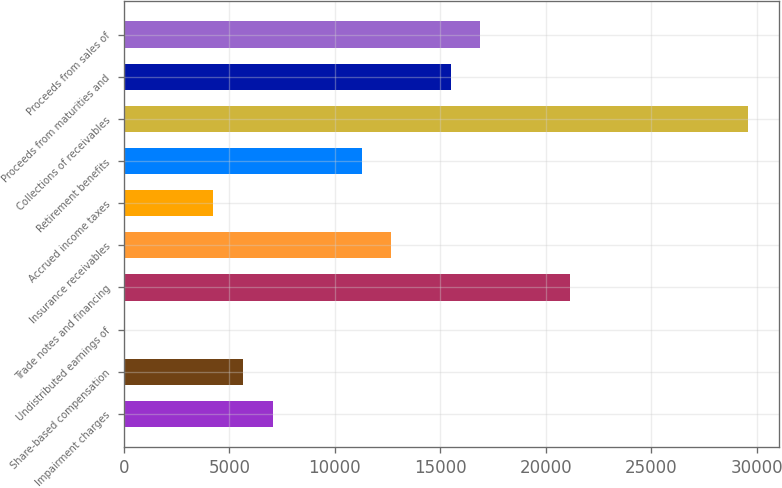Convert chart to OTSL. <chart><loc_0><loc_0><loc_500><loc_500><bar_chart><fcel>Impairment charges<fcel>Share-based compensation<fcel>Undistributed earnings of<fcel>Trade notes and financing<fcel>Insurance receivables<fcel>Accrued income taxes<fcel>Retirement benefits<fcel>Collections of receivables<fcel>Proceeds from maturities and<fcel>Proceeds from sales of<nl><fcel>7048.55<fcel>5640.66<fcel>9.1<fcel>21127.5<fcel>12680.1<fcel>4232.77<fcel>11272.2<fcel>29574.8<fcel>15495.9<fcel>16903.8<nl></chart> 